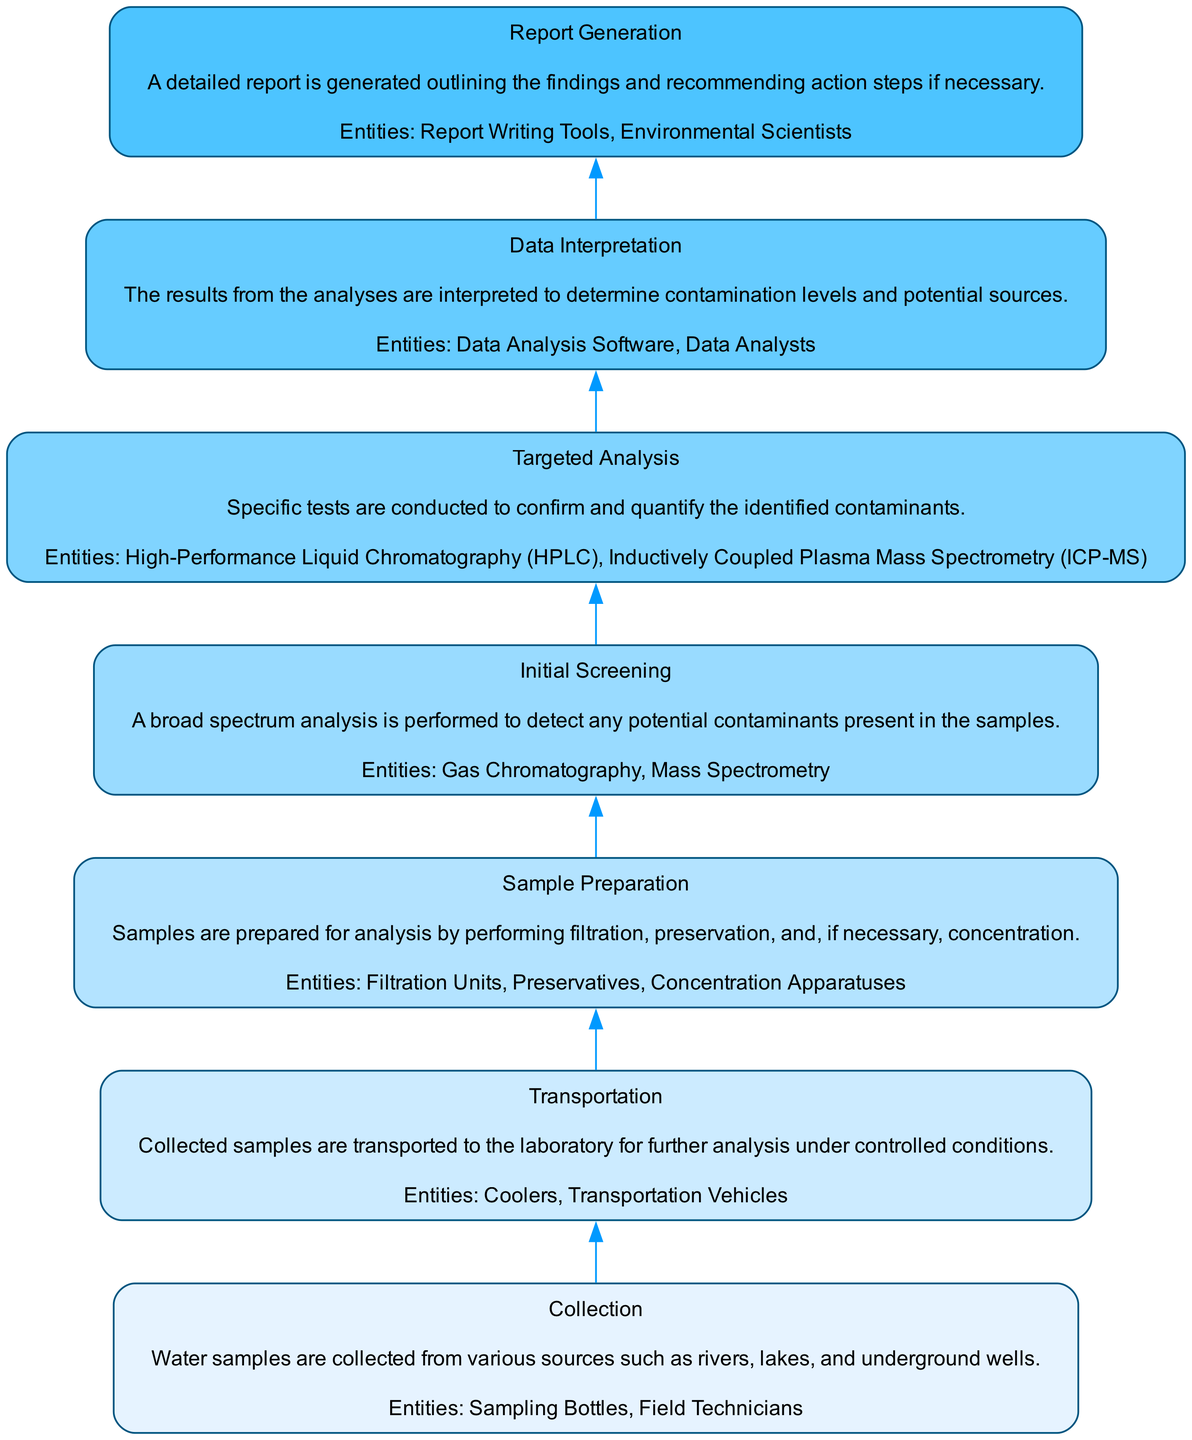What is the first stage in the process? The first stage in the process, as shown at the bottom of the diagram, is "Collection", which involves gathering water samples from different sources.
Answer: Collection How many stages are depicted in the diagram? Counting the stages listed in the diagram, there are seven distinct stages clearly identified from bottom to top.
Answer: Seven What entities are involved in the "Transportation" stage? The "Transportation" stage specifies that the entities involved are "Coolers" and "Transportation Vehicles" for moving collected samples to the laboratory.
Answer: Coolers, Transportation Vehicles What analysis method is used in the "Initial Screening"? The "Initial Screening" stage indicates that "Gas Chromatography" and "Mass Spectrometry" are the analysis methods employed to detect potential contaminants.
Answer: Gas Chromatography, Mass Spectrometry What is the final output of the process? The final output of the process, as indicated at the top of the diagram, is "Report Generation", which involves creating a detailed report of the findings and recommendations.
Answer: Report Generation Which stage comes directly after "Sample Preparation"? Looking at the flow from the bottom to the top, the stage that follows "Sample Preparation" is "Initial Screening", where broad-spectrum analysis takes place.
Answer: Initial Screening What is the primary focus during the "Targeted Analysis" stage? The "Targeted Analysis" stage focuses on conducting specific tests to confirm and quantify the identified contaminants present in the water samples.
Answer: Confirm and quantify contaminants In which stage are data analysis activities performed? Data analysis activities are performed in the "Data Interpretation" stage, where the results from the analyses are evaluated to determine contamination levels and potential sources.
Answer: Data Interpretation What type of software is used for data analysis? The diagram specifies that "Data Analysis Software" is employed in the "Data Interpretation" stage to help analyze the results from the water sample testing.
Answer: Data Analysis Software 